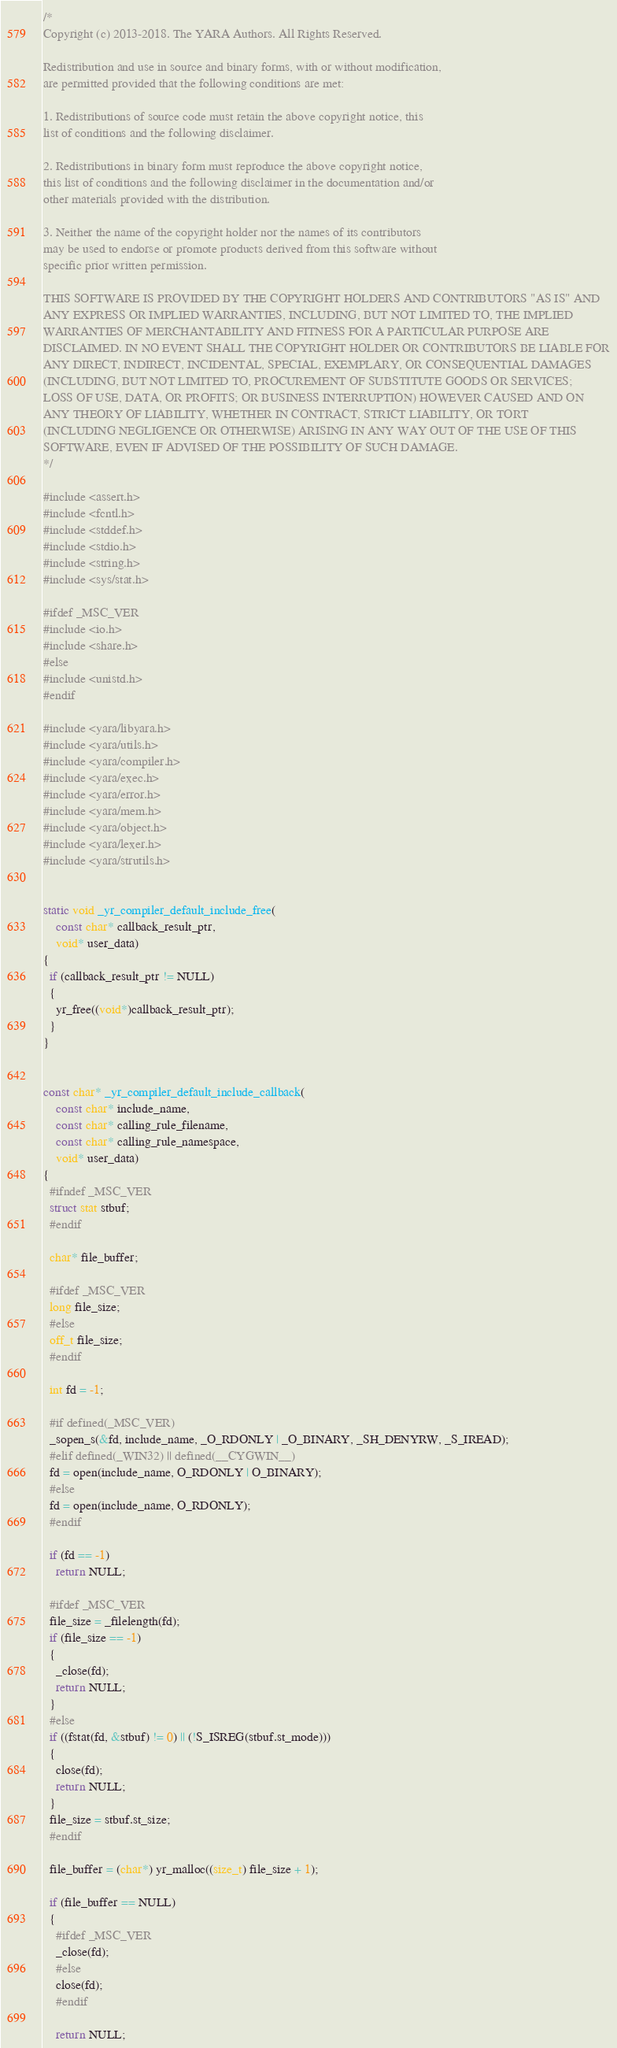<code> <loc_0><loc_0><loc_500><loc_500><_C_>/*
Copyright (c) 2013-2018. The YARA Authors. All Rights Reserved.

Redistribution and use in source and binary forms, with or without modification,
are permitted provided that the following conditions are met:

1. Redistributions of source code must retain the above copyright notice, this
list of conditions and the following disclaimer.

2. Redistributions in binary form must reproduce the above copyright notice,
this list of conditions and the following disclaimer in the documentation and/or
other materials provided with the distribution.

3. Neither the name of the copyright holder nor the names of its contributors
may be used to endorse or promote products derived from this software without
specific prior written permission.

THIS SOFTWARE IS PROVIDED BY THE COPYRIGHT HOLDERS AND CONTRIBUTORS "AS IS" AND
ANY EXPRESS OR IMPLIED WARRANTIES, INCLUDING, BUT NOT LIMITED TO, THE IMPLIED
WARRANTIES OF MERCHANTABILITY AND FITNESS FOR A PARTICULAR PURPOSE ARE
DISCLAIMED. IN NO EVENT SHALL THE COPYRIGHT HOLDER OR CONTRIBUTORS BE LIABLE FOR
ANY DIRECT, INDIRECT, INCIDENTAL, SPECIAL, EXEMPLARY, OR CONSEQUENTIAL DAMAGES
(INCLUDING, BUT NOT LIMITED TO, PROCUREMENT OF SUBSTITUTE GOODS OR SERVICES;
LOSS OF USE, DATA, OR PROFITS; OR BUSINESS INTERRUPTION) HOWEVER CAUSED AND ON
ANY THEORY OF LIABILITY, WHETHER IN CONTRACT, STRICT LIABILITY, OR TORT
(INCLUDING NEGLIGENCE OR OTHERWISE) ARISING IN ANY WAY OUT OF THE USE OF THIS
SOFTWARE, EVEN IF ADVISED OF THE POSSIBILITY OF SUCH DAMAGE.
*/

#include <assert.h>
#include <fcntl.h>
#include <stddef.h>
#include <stdio.h>
#include <string.h>
#include <sys/stat.h>

#ifdef _MSC_VER
#include <io.h>
#include <share.h>
#else
#include <unistd.h>
#endif

#include <yara/libyara.h>
#include <yara/utils.h>
#include <yara/compiler.h>
#include <yara/exec.h>
#include <yara/error.h>
#include <yara/mem.h>
#include <yara/object.h>
#include <yara/lexer.h>
#include <yara/strutils.h>


static void _yr_compiler_default_include_free(
    const char* callback_result_ptr,
    void* user_data)
{
  if (callback_result_ptr != NULL)
  {
    yr_free((void*)callback_result_ptr);
  }
}


const char* _yr_compiler_default_include_callback(
    const char* include_name,
    const char* calling_rule_filename,
    const char* calling_rule_namespace,
    void* user_data)
{
  #ifndef _MSC_VER
  struct stat stbuf;
  #endif

  char* file_buffer;

  #ifdef _MSC_VER
  long file_size;
  #else
  off_t file_size;
  #endif

  int fd = -1;

  #if defined(_MSC_VER)
  _sopen_s(&fd, include_name, _O_RDONLY | _O_BINARY, _SH_DENYRW, _S_IREAD);
  #elif defined(_WIN32) || defined(__CYGWIN__)
  fd = open(include_name, O_RDONLY | O_BINARY);
  #else
  fd = open(include_name, O_RDONLY);
  #endif

  if (fd == -1)
    return NULL;

  #ifdef _MSC_VER
  file_size = _filelength(fd);
  if (file_size == -1)
  {
    _close(fd);
    return NULL;
  }
  #else
  if ((fstat(fd, &stbuf) != 0) || (!S_ISREG(stbuf.st_mode)))
  {
    close(fd);
    return NULL;
  }
  file_size = stbuf.st_size;
  #endif

  file_buffer = (char*) yr_malloc((size_t) file_size + 1);

  if (file_buffer == NULL)
  {
    #ifdef _MSC_VER
    _close(fd);
    #else
    close(fd);
    #endif

    return NULL;</code> 